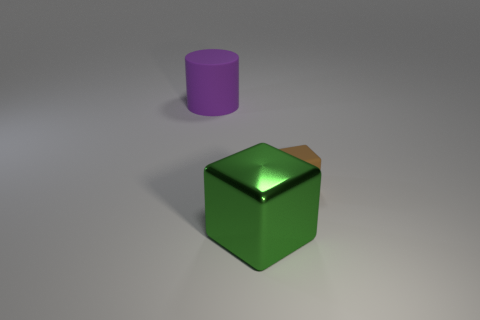Add 3 tiny gray balls. How many objects exist? 6 Subtract all cubes. How many objects are left? 1 Add 3 cylinders. How many cylinders are left? 4 Add 1 big cylinders. How many big cylinders exist? 2 Subtract 0 purple spheres. How many objects are left? 3 Subtract all cyan spheres. Subtract all big shiny cubes. How many objects are left? 2 